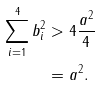<formula> <loc_0><loc_0><loc_500><loc_500>\sum _ { i = 1 } ^ { 4 } b _ { i } ^ { 2 } & > 4 \frac { a ^ { 2 } } { 4 } \\ & = a ^ { 2 } .</formula> 